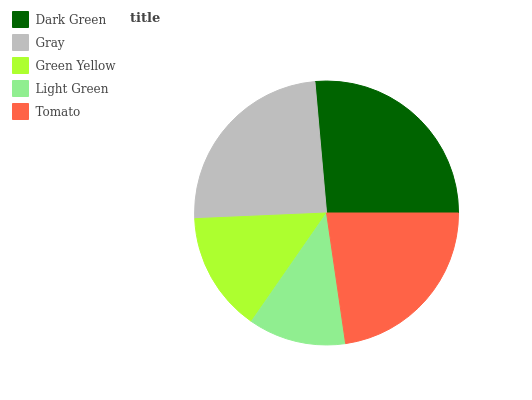Is Light Green the minimum?
Answer yes or no. Yes. Is Dark Green the maximum?
Answer yes or no. Yes. Is Gray the minimum?
Answer yes or no. No. Is Gray the maximum?
Answer yes or no. No. Is Dark Green greater than Gray?
Answer yes or no. Yes. Is Gray less than Dark Green?
Answer yes or no. Yes. Is Gray greater than Dark Green?
Answer yes or no. No. Is Dark Green less than Gray?
Answer yes or no. No. Is Tomato the high median?
Answer yes or no. Yes. Is Tomato the low median?
Answer yes or no. Yes. Is Light Green the high median?
Answer yes or no. No. Is Green Yellow the low median?
Answer yes or no. No. 